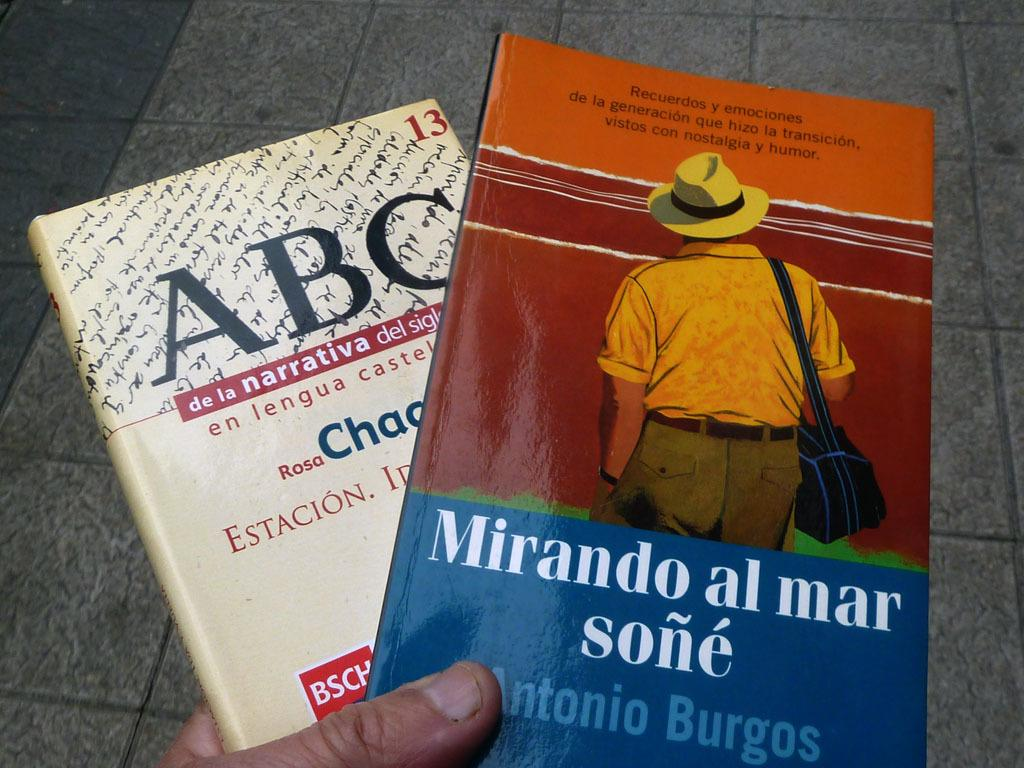<image>
Present a compact description of the photo's key features. Book titled "Mirando al mar sone" by Antonio Burgos showing a man with his hands in his pockets on the cover. 